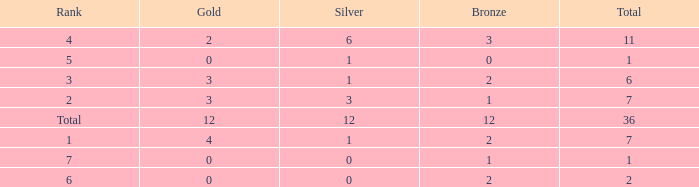What is the number of bronze medals when there are fewer than 0 silver medals? None. 